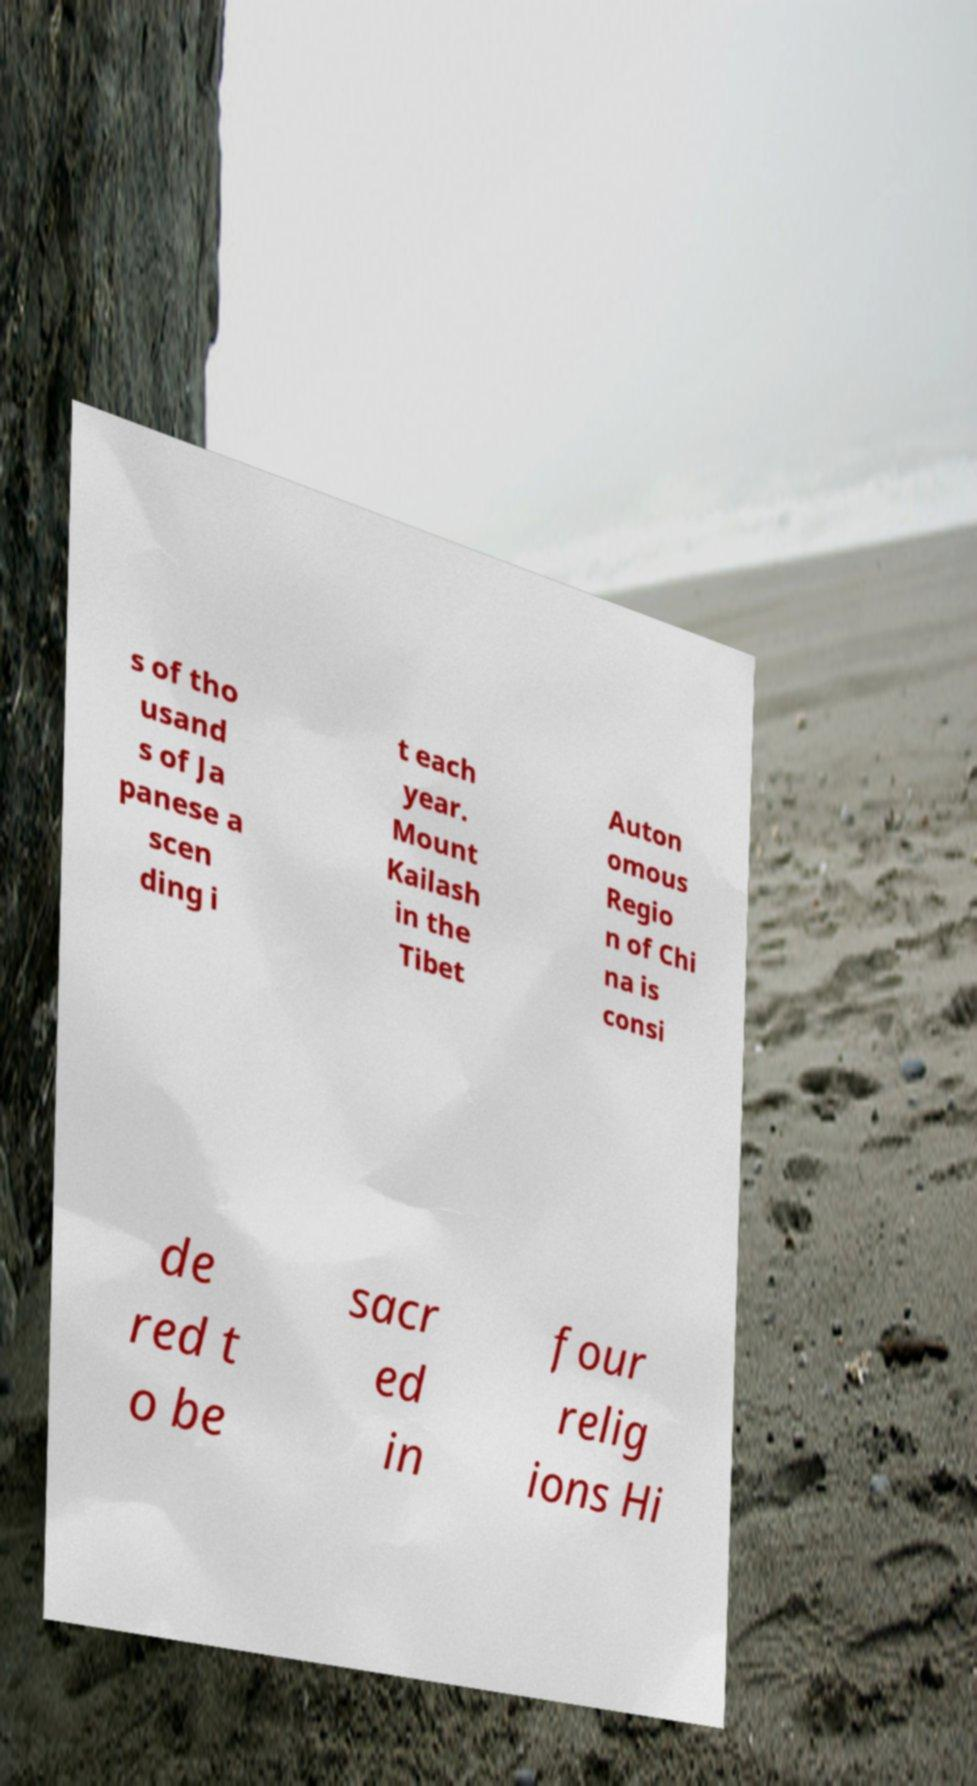Can you read and provide the text displayed in the image?This photo seems to have some interesting text. Can you extract and type it out for me? s of tho usand s of Ja panese a scen ding i t each year. Mount Kailash in the Tibet Auton omous Regio n of Chi na is consi de red t o be sacr ed in four relig ions Hi 